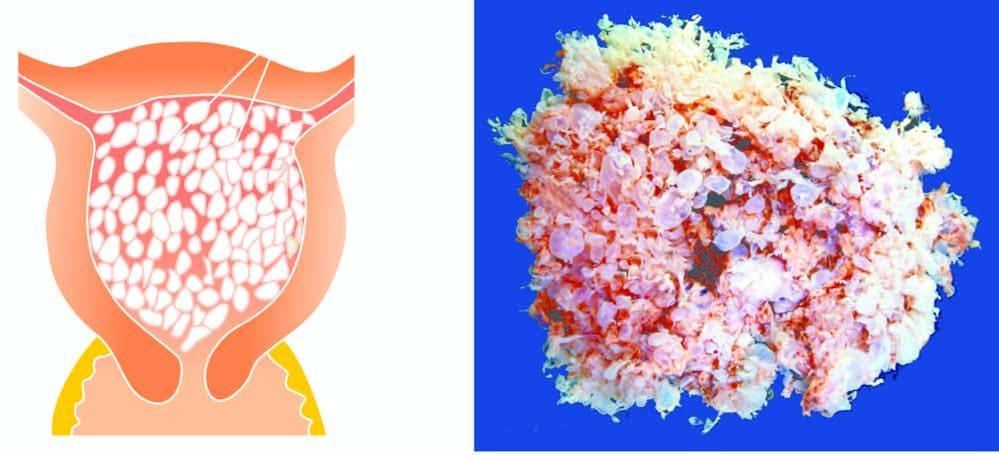does the congophilic areas show numerous, variable-sized, grape-like translucent vesicles containing clear fluid?
Answer the question using a single word or phrase. No 